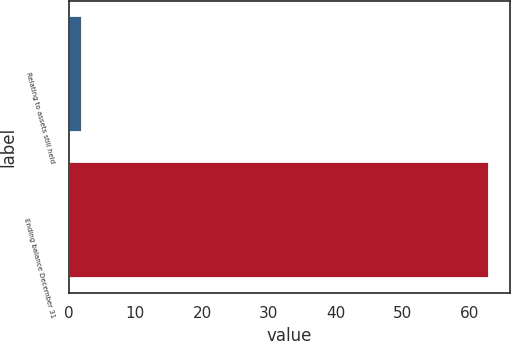<chart> <loc_0><loc_0><loc_500><loc_500><bar_chart><fcel>Relating to assets still held<fcel>Ending balance December 31<nl><fcel>2<fcel>63<nl></chart> 